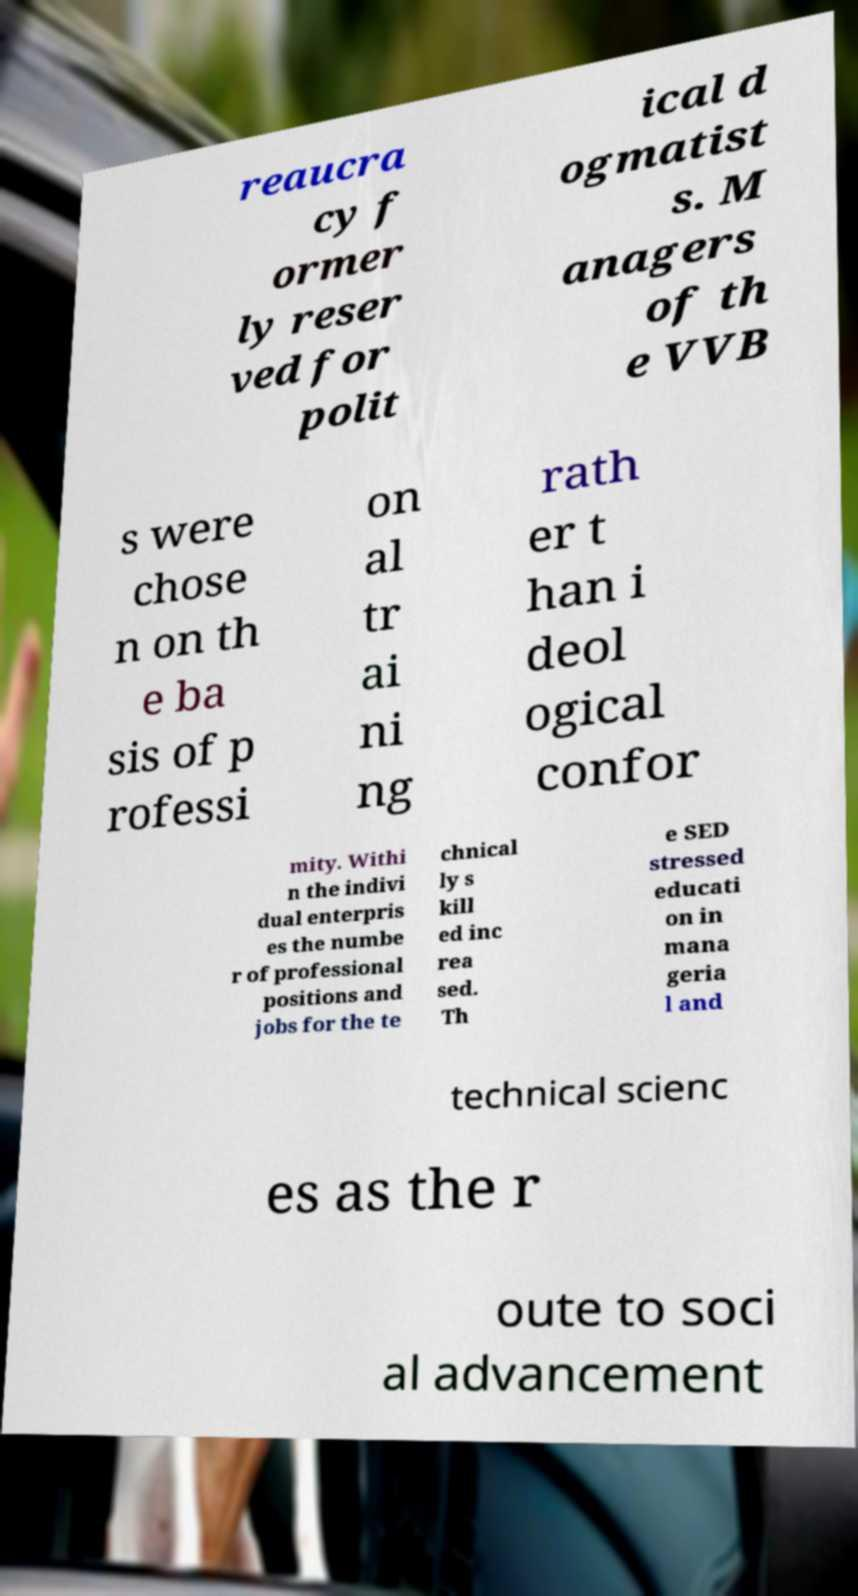Please read and relay the text visible in this image. What does it say? reaucra cy f ormer ly reser ved for polit ical d ogmatist s. M anagers of th e VVB s were chose n on th e ba sis of p rofessi on al tr ai ni ng rath er t han i deol ogical confor mity. Withi n the indivi dual enterpris es the numbe r of professional positions and jobs for the te chnical ly s kill ed inc rea sed. Th e SED stressed educati on in mana geria l and technical scienc es as the r oute to soci al advancement 